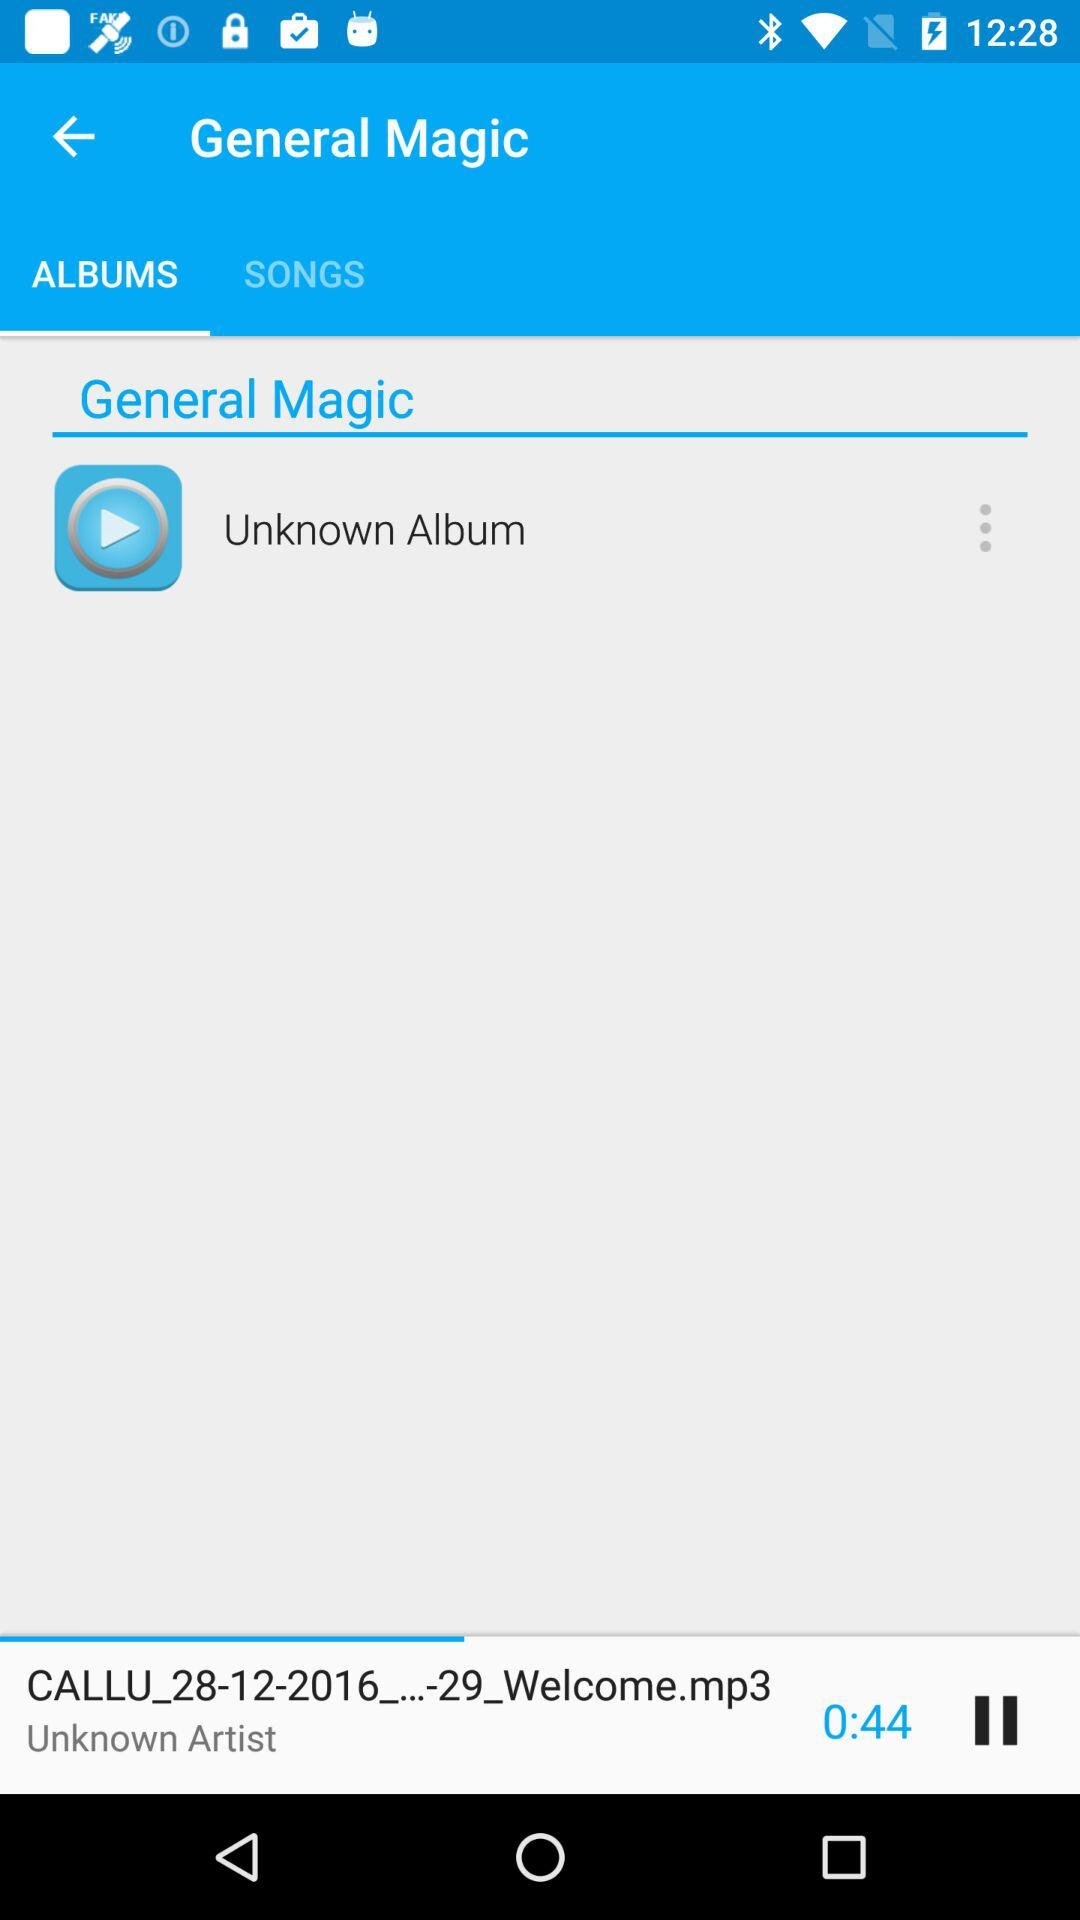Which audio is playing? The audio that is playing is "CALLU_28-12-2016_...-29_Welcome.mp3". 